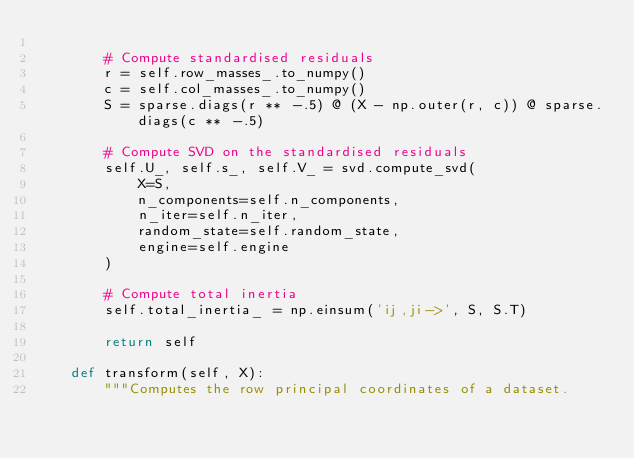<code> <loc_0><loc_0><loc_500><loc_500><_Python_>
        # Compute standardised residuals
        r = self.row_masses_.to_numpy()
        c = self.col_masses_.to_numpy()
        S = sparse.diags(r ** -.5) @ (X - np.outer(r, c)) @ sparse.diags(c ** -.5)

        # Compute SVD on the standardised residuals
        self.U_, self.s_, self.V_ = svd.compute_svd(
            X=S,
            n_components=self.n_components,
            n_iter=self.n_iter,
            random_state=self.random_state,
            engine=self.engine
        )

        # Compute total inertia
        self.total_inertia_ = np.einsum('ij,ji->', S, S.T)

        return self

    def transform(self, X):
        """Computes the row principal coordinates of a dataset.
</code> 